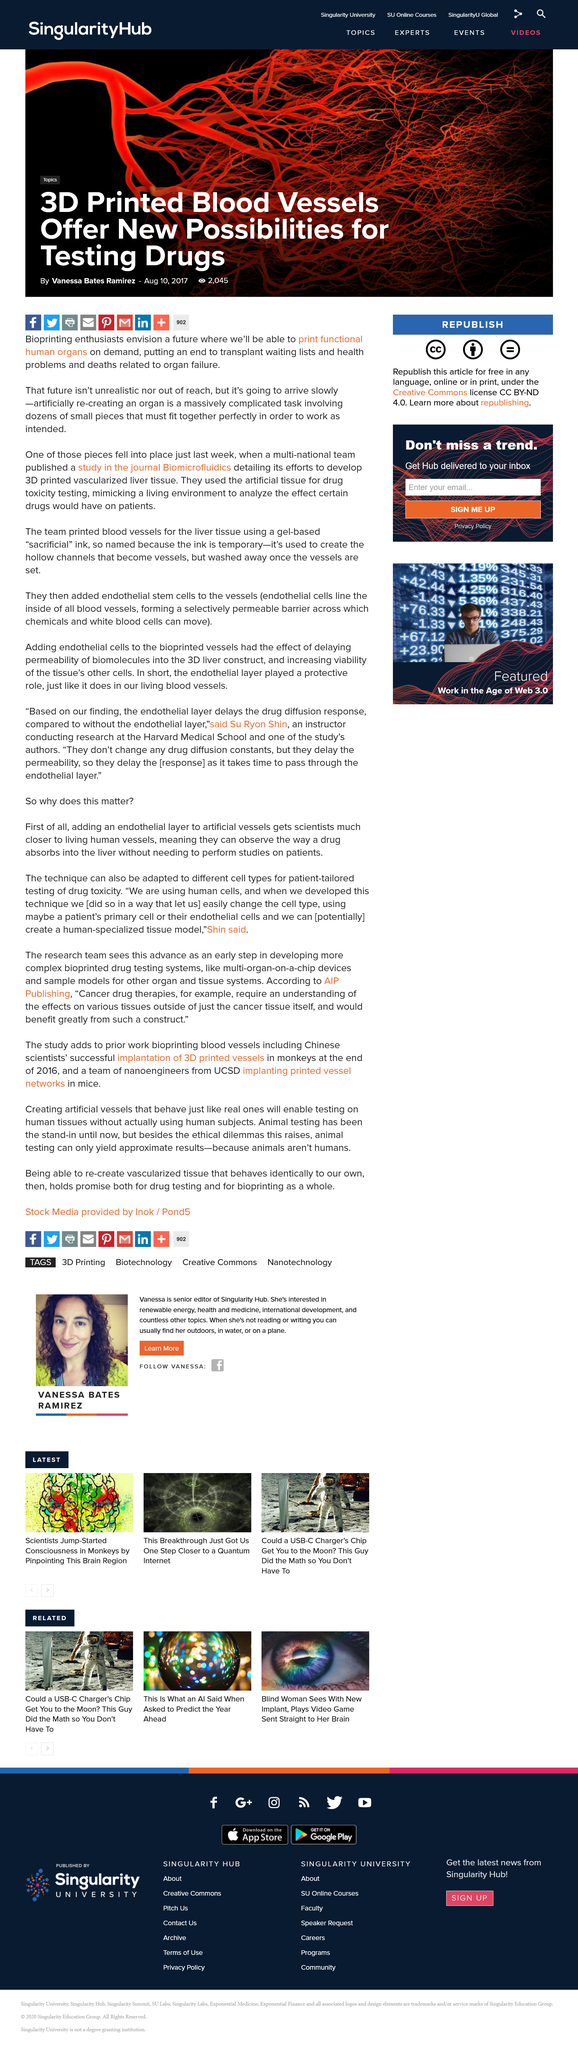Outline some significant characteristics in this image. Recreating an organ involves the precise assembly of dozens of intricate pieces that must be assembled flawlessly in order for the organ to function as intended. Bioprinting enthusiasts envision a future where we will be able to print functional human organs on demand, allowing for the creation of personalized, living organ tissues for medical purposes. Vanessa Bates Ramirez wrote the article titled "3D Printed Blood Vessels Offer New Possibilities for Testing Drugs. 